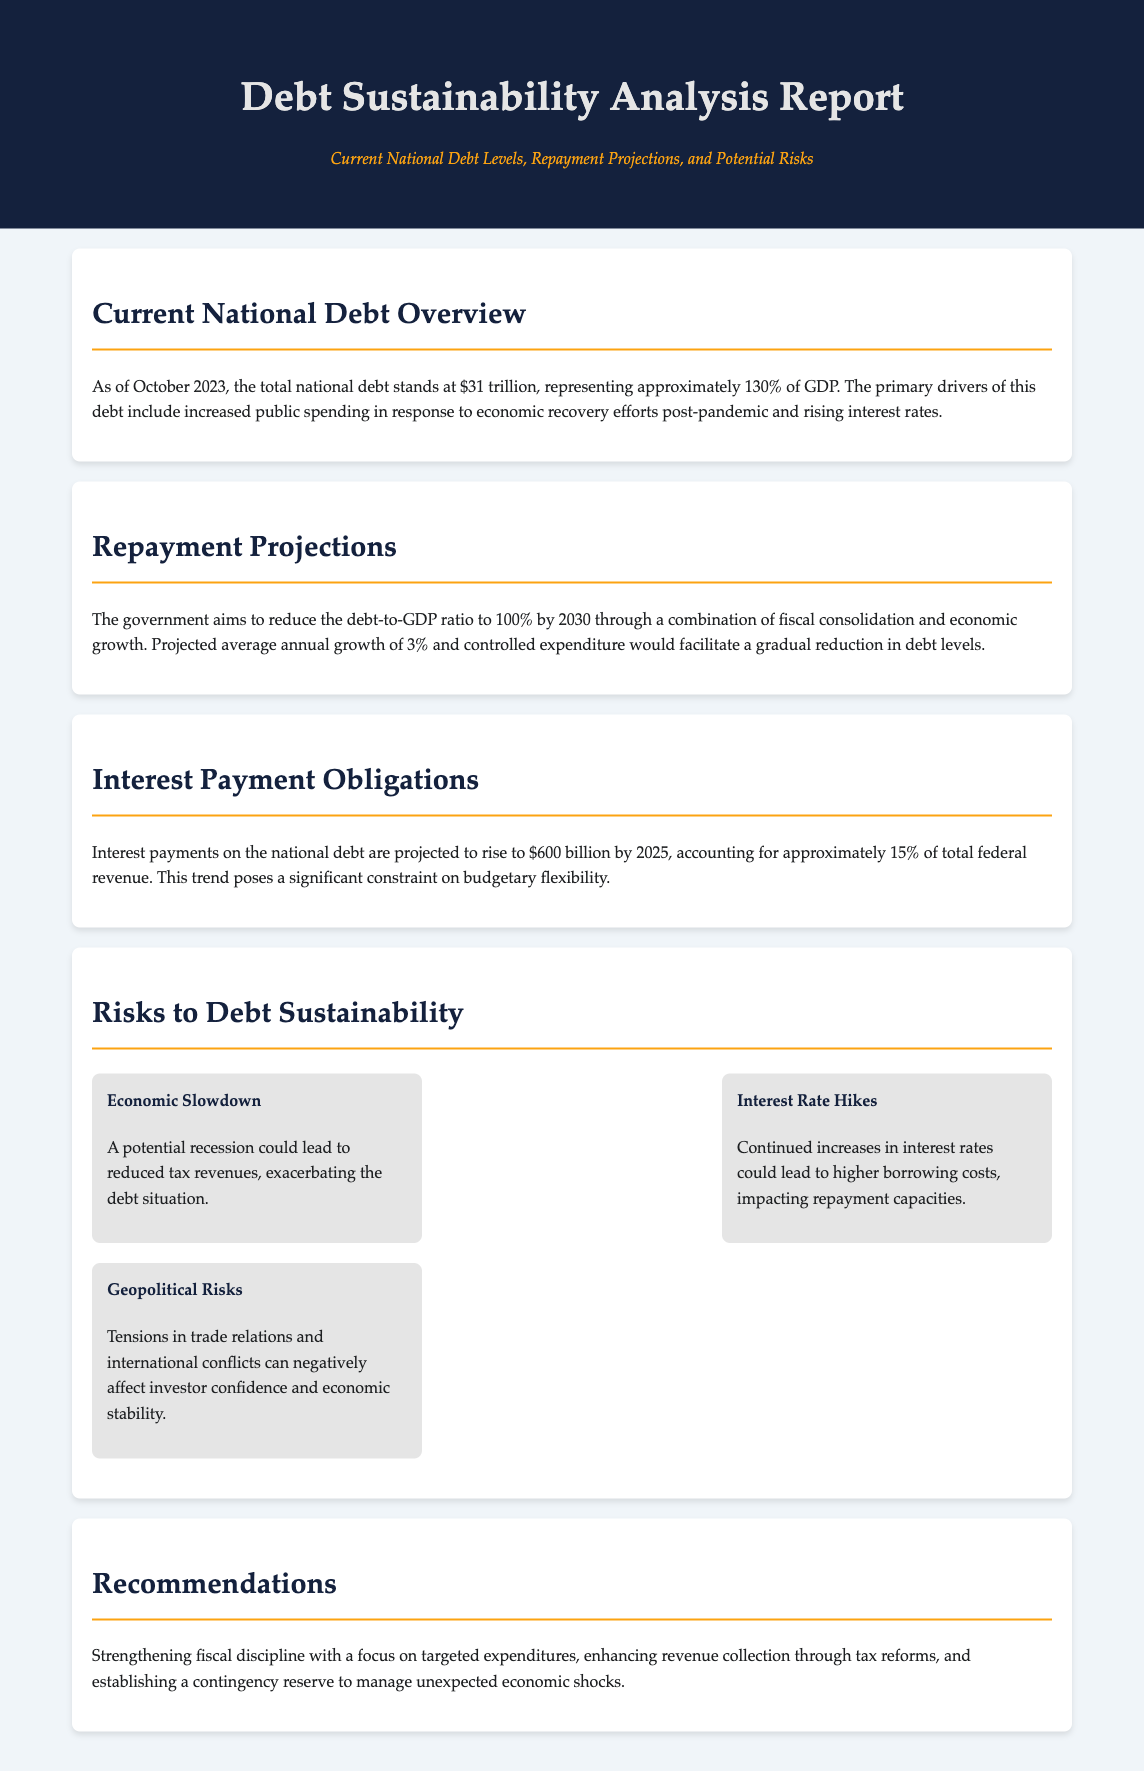what is the total national debt as of October 2023? The document states that the total national debt stands at $31 trillion.
Answer: $31 trillion what percentage of GDP does the national debt represent? It is mentioned that the national debt represents approximately 130% of GDP.
Answer: 130% what is the projected interest payment on the national debt by 2025? The report indicates that interest payments are projected to rise to $600 billion by 2025.
Answer: $600 billion by what year does the government aim to reduce the debt-to-GDP ratio to 100%? According to the document, the government aims to achieve this by the year 2030.
Answer: 2030 what is one of the primary drivers of increased national debt? Increased public spending in response to economic recovery efforts post-pandemic is noted as a primary driver.
Answer: Increased public spending what is the projected average annual growth rate that could help reduce debt levels? The document states a projected average annual growth of 3%.
Answer: 3% what is one potential risk to debt sustainability mentioned in the report? The document lists economic slowdown as one of the risks.
Answer: Economic slowdown how much of total federal revenue will interest payments account for by 2025? The report states that interest payments will account for approximately 15% of total federal revenue.
Answer: 15% what is a recommendation for strengthening fiscal discipline? The document recommends focusing on targeted expenditures.
Answer: Targeted expenditures 